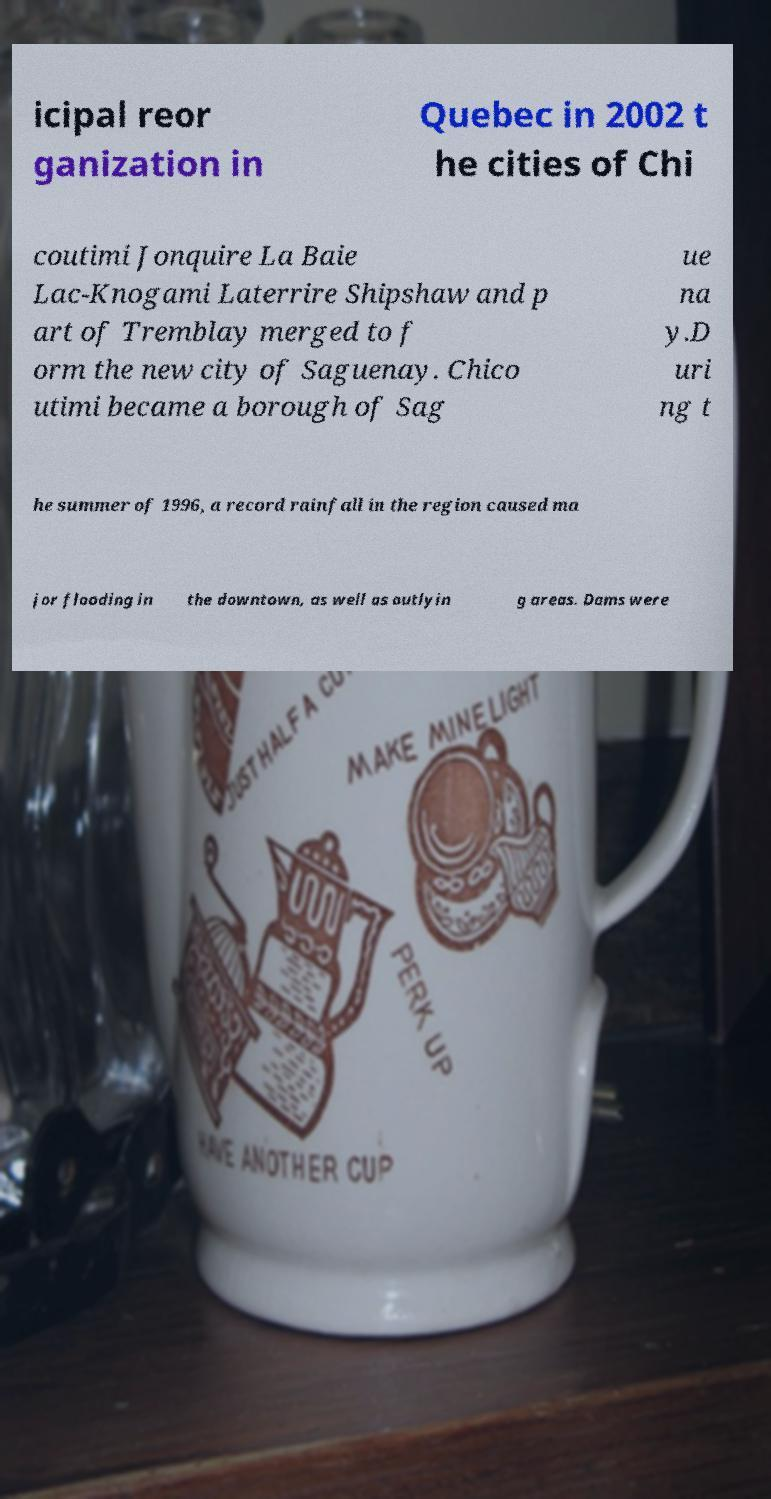For documentation purposes, I need the text within this image transcribed. Could you provide that? icipal reor ganization in Quebec in 2002 t he cities of Chi coutimi Jonquire La Baie Lac-Knogami Laterrire Shipshaw and p art of Tremblay merged to f orm the new city of Saguenay. Chico utimi became a borough of Sag ue na y.D uri ng t he summer of 1996, a record rainfall in the region caused ma jor flooding in the downtown, as well as outlyin g areas. Dams were 